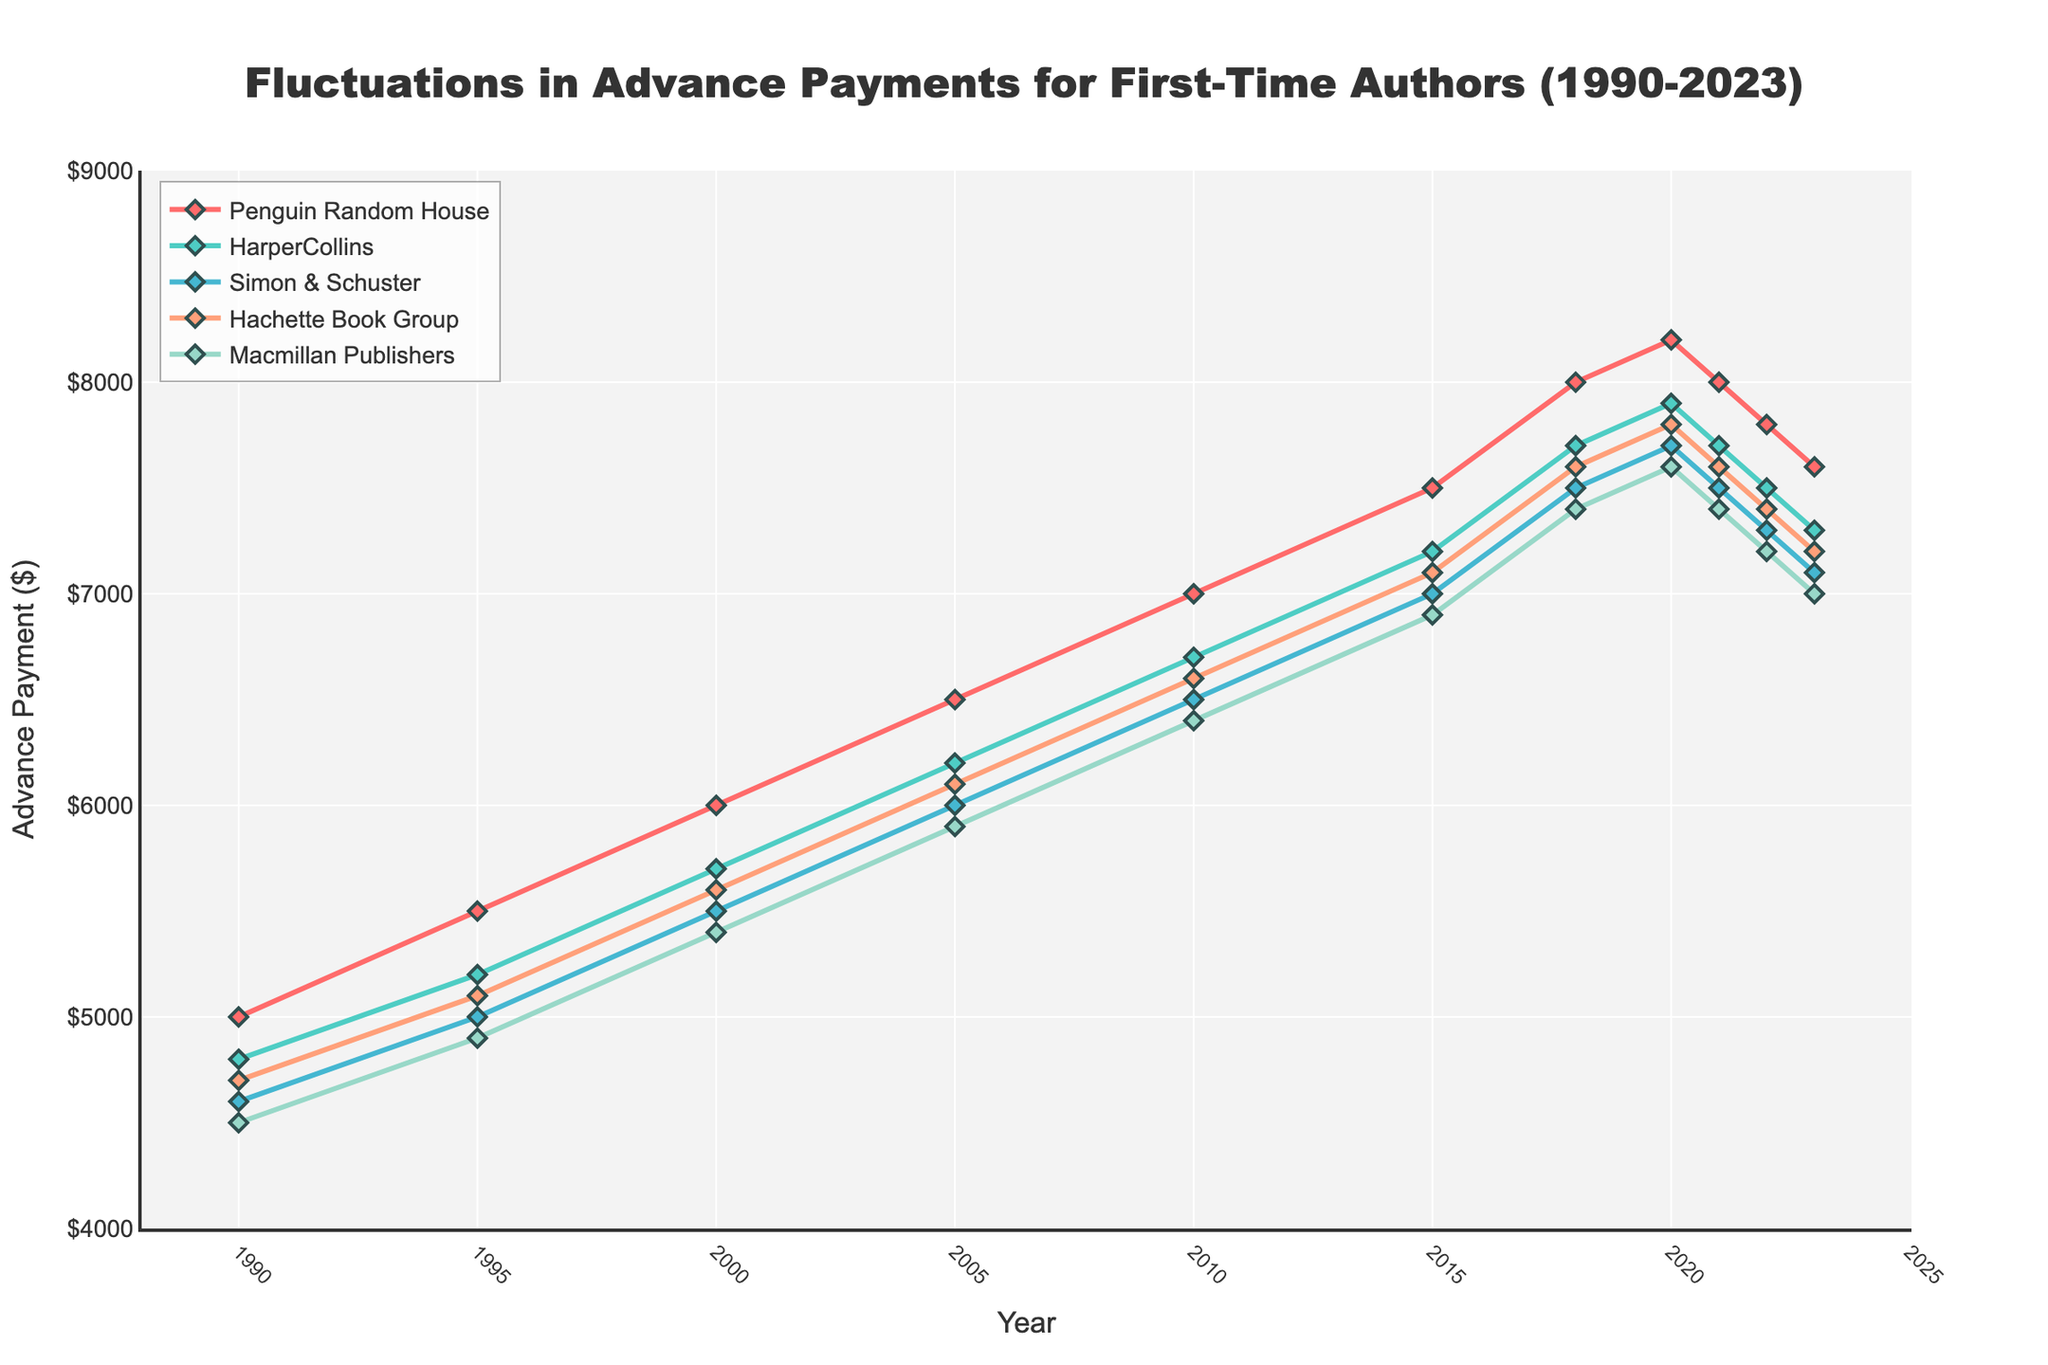What is the highest advance payment offered to first-time authors by Penguin Random House during the period 1990-2023? The highest point on Penguin Random House's line on the chart represents the highest advance payment. In 2020, the advance payment was $8200.
Answer: $8200 Which publishing house offered the lowest advance payment to first-time authors in 2023? Examine the endpoints for each line in 2023. The lowest point corresponds to Macmillan Publishers, with an advance payment of $7000.
Answer: Macmillan Publishers How has Simon & Schuster's advance payment trend changed between 1990 and 2023? Simon & Schuster's line shows an upward trend from 4600 in 1990 to a peak in 2020 at 7700, followed by a decline to 7100 in 2023.
Answer: Increased then decreased What is the difference in advance payments between HarperCollins and Hachette Book Group in 2022? Subtract Hachette's value in 2022 ($7400) from HarperCollins' value ($7500).
Answer: $100 Which year did Penguin Random House offer the same advance payment amount as in 2023? Find the point where Penguin Random House's line meets $7600, which corresponds to the year 2010.
Answer: 2010 What color represents the line for Macmillan Publishers? The line colors listed indicate that Macmillan Publishers is represented by the color in the final position, which is a shade of green.
Answer: Green In which year did the advance payments from all publishing houses peak? Identify the year with the highest points in all lines. All lines peak around 2020.
Answer: 2020 Calculate the average advance payment across all publishers in 2015. Sum the 2015 values ($7500 + $7200 + $7000 + $7100 + $6900) and divide by 5. Average = (7500 + 7200 + 7000 + 7100 + 6900) / 5 = $7140.
Answer: $7140 Compare the increase in advance payments from 1990 to 2000 for Penguin Random House and Hachette Book Group. Which saw a larger increase? Increase for Penguin Random House = $6000 - $5000 = $1000. Increase for Hachette Book Group = $5600 - $4700 = $900.
Answer: Penguin Random House How did the trend for Macmillan Publishers' advance payments change between 2015 and 2023? Macmillan Publishers' payments rose from $6900 in 2015 to peak at $7600 in 2020 and then declined to $7000 in 2023.
Answer: Increased then decreased 